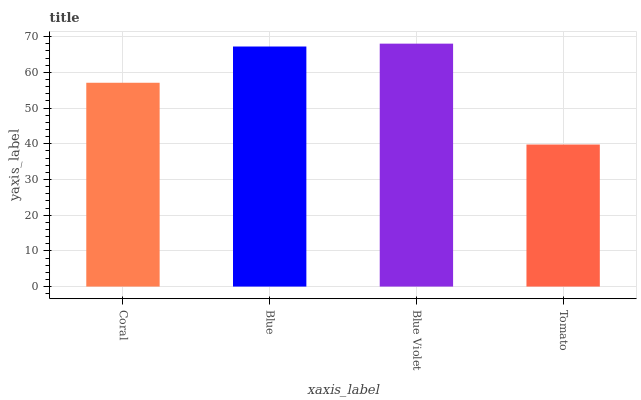Is Tomato the minimum?
Answer yes or no. Yes. Is Blue Violet the maximum?
Answer yes or no. Yes. Is Blue the minimum?
Answer yes or no. No. Is Blue the maximum?
Answer yes or no. No. Is Blue greater than Coral?
Answer yes or no. Yes. Is Coral less than Blue?
Answer yes or no. Yes. Is Coral greater than Blue?
Answer yes or no. No. Is Blue less than Coral?
Answer yes or no. No. Is Blue the high median?
Answer yes or no. Yes. Is Coral the low median?
Answer yes or no. Yes. Is Blue Violet the high median?
Answer yes or no. No. Is Blue Violet the low median?
Answer yes or no. No. 